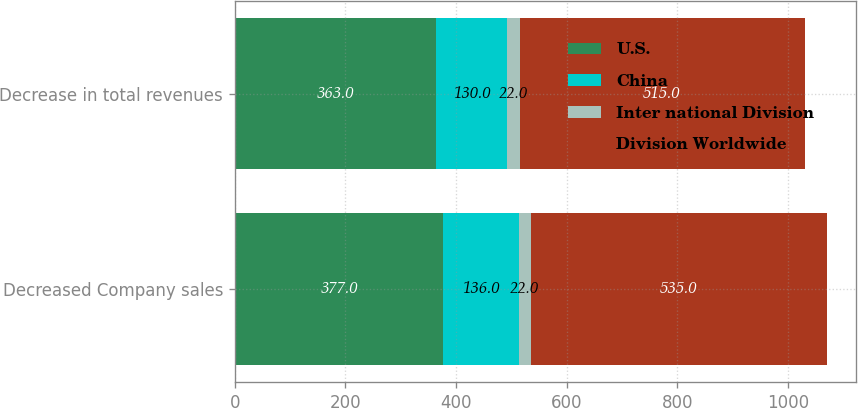Convert chart. <chart><loc_0><loc_0><loc_500><loc_500><stacked_bar_chart><ecel><fcel>Decreased Company sales<fcel>Decrease in total revenues<nl><fcel>U.S.<fcel>377<fcel>363<nl><fcel>China<fcel>136<fcel>130<nl><fcel>Inter national Division<fcel>22<fcel>22<nl><fcel>Division Worldwide<fcel>535<fcel>515<nl></chart> 